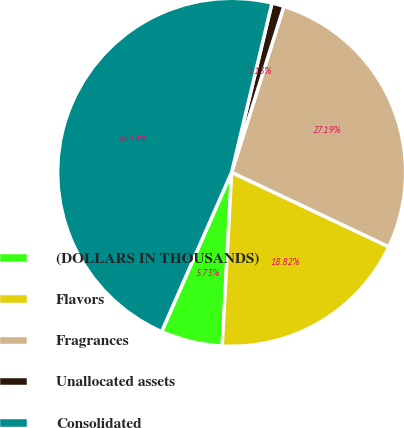Convert chart to OTSL. <chart><loc_0><loc_0><loc_500><loc_500><pie_chart><fcel>(DOLLARS IN THOUSANDS)<fcel>Flavors<fcel>Fragrances<fcel>Unallocated assets<fcel>Consolidated<nl><fcel>5.73%<fcel>18.82%<fcel>27.19%<fcel>1.13%<fcel>47.14%<nl></chart> 